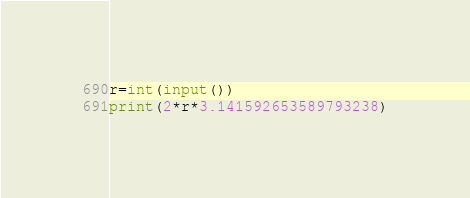Convert code to text. <code><loc_0><loc_0><loc_500><loc_500><_Python_>r=int(input())
print(2*r*3.141592653589793238)</code> 